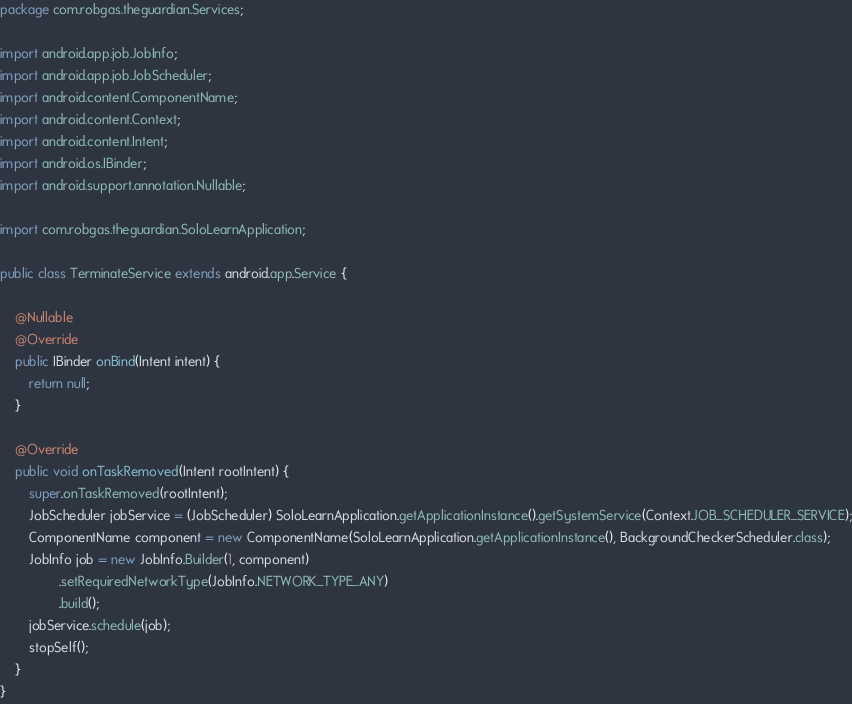Convert code to text. <code><loc_0><loc_0><loc_500><loc_500><_Java_>package com.robgas.theguardian.Services;

import android.app.job.JobInfo;
import android.app.job.JobScheduler;
import android.content.ComponentName;
import android.content.Context;
import android.content.Intent;
import android.os.IBinder;
import android.support.annotation.Nullable;

import com.robgas.theguardian.SoloLearnApplication;

public class TerminateService extends android.app.Service {

    @Nullable
    @Override
    public IBinder onBind(Intent intent) {
        return null;
    }

    @Override
    public void onTaskRemoved(Intent rootIntent) {
        super.onTaskRemoved(rootIntent);
        JobScheduler jobService = (JobScheduler) SoloLearnApplication.getApplicationInstance().getSystemService(Context.JOB_SCHEDULER_SERVICE);
        ComponentName component = new ComponentName(SoloLearnApplication.getApplicationInstance(), BackgroundCheckerScheduler.class);
        JobInfo job = new JobInfo.Builder(1, component)
                .setRequiredNetworkType(JobInfo.NETWORK_TYPE_ANY)
                .build();
        jobService.schedule(job);
        stopSelf();
    }
}
</code> 